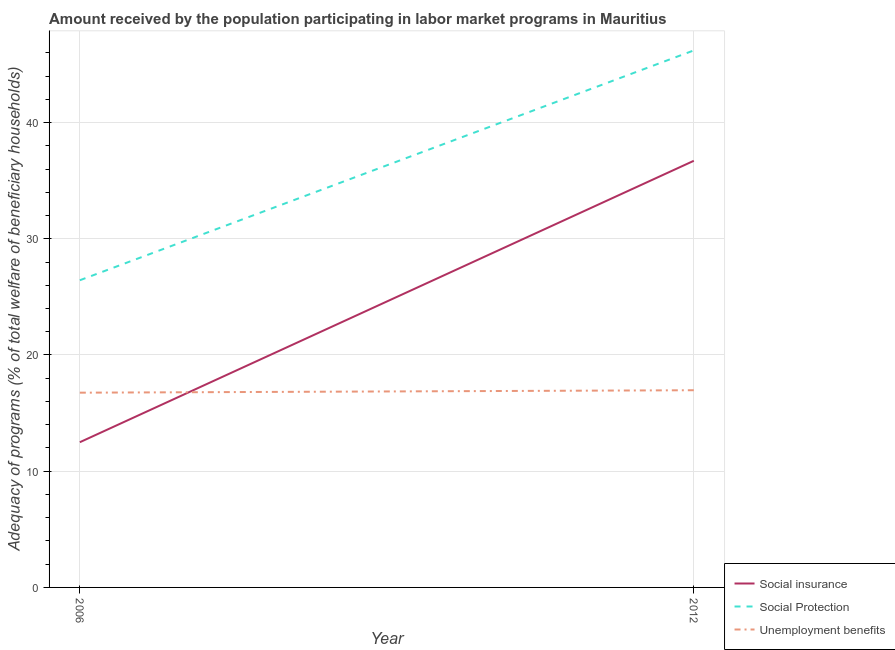How many different coloured lines are there?
Your response must be concise. 3. Is the number of lines equal to the number of legend labels?
Ensure brevity in your answer.  Yes. What is the amount received by the population participating in social protection programs in 2012?
Keep it short and to the point. 46.21. Across all years, what is the maximum amount received by the population participating in social insurance programs?
Your response must be concise. 36.71. Across all years, what is the minimum amount received by the population participating in social protection programs?
Ensure brevity in your answer.  26.43. What is the total amount received by the population participating in unemployment benefits programs in the graph?
Ensure brevity in your answer.  33.73. What is the difference between the amount received by the population participating in social insurance programs in 2006 and that in 2012?
Make the answer very short. -24.22. What is the difference between the amount received by the population participating in social protection programs in 2012 and the amount received by the population participating in social insurance programs in 2006?
Provide a succinct answer. 33.71. What is the average amount received by the population participating in unemployment benefits programs per year?
Your answer should be very brief. 16.86. In the year 2012, what is the difference between the amount received by the population participating in social insurance programs and amount received by the population participating in unemployment benefits programs?
Keep it short and to the point. 19.74. What is the ratio of the amount received by the population participating in social insurance programs in 2006 to that in 2012?
Give a very brief answer. 0.34. Is the amount received by the population participating in social protection programs in 2006 less than that in 2012?
Ensure brevity in your answer.  Yes. Is the amount received by the population participating in unemployment benefits programs strictly greater than the amount received by the population participating in social insurance programs over the years?
Make the answer very short. No. Is the amount received by the population participating in unemployment benefits programs strictly less than the amount received by the population participating in social insurance programs over the years?
Your response must be concise. No. How many years are there in the graph?
Provide a short and direct response. 2. What is the difference between two consecutive major ticks on the Y-axis?
Your answer should be very brief. 10. Where does the legend appear in the graph?
Make the answer very short. Bottom right. What is the title of the graph?
Ensure brevity in your answer.  Amount received by the population participating in labor market programs in Mauritius. Does "Negligence towards kids" appear as one of the legend labels in the graph?
Make the answer very short. No. What is the label or title of the Y-axis?
Provide a succinct answer. Adequacy of programs (% of total welfare of beneficiary households). What is the Adequacy of programs (% of total welfare of beneficiary households) in Social insurance in 2006?
Offer a very short reply. 12.49. What is the Adequacy of programs (% of total welfare of beneficiary households) of Social Protection in 2006?
Your response must be concise. 26.43. What is the Adequacy of programs (% of total welfare of beneficiary households) in Unemployment benefits in 2006?
Keep it short and to the point. 16.76. What is the Adequacy of programs (% of total welfare of beneficiary households) of Social insurance in 2012?
Offer a terse response. 36.71. What is the Adequacy of programs (% of total welfare of beneficiary households) of Social Protection in 2012?
Provide a short and direct response. 46.21. What is the Adequacy of programs (% of total welfare of beneficiary households) in Unemployment benefits in 2012?
Provide a short and direct response. 16.97. Across all years, what is the maximum Adequacy of programs (% of total welfare of beneficiary households) in Social insurance?
Offer a very short reply. 36.71. Across all years, what is the maximum Adequacy of programs (% of total welfare of beneficiary households) of Social Protection?
Offer a terse response. 46.21. Across all years, what is the maximum Adequacy of programs (% of total welfare of beneficiary households) in Unemployment benefits?
Your response must be concise. 16.97. Across all years, what is the minimum Adequacy of programs (% of total welfare of beneficiary households) of Social insurance?
Your answer should be compact. 12.49. Across all years, what is the minimum Adequacy of programs (% of total welfare of beneficiary households) of Social Protection?
Provide a succinct answer. 26.43. Across all years, what is the minimum Adequacy of programs (% of total welfare of beneficiary households) in Unemployment benefits?
Give a very brief answer. 16.76. What is the total Adequacy of programs (% of total welfare of beneficiary households) of Social insurance in the graph?
Give a very brief answer. 49.2. What is the total Adequacy of programs (% of total welfare of beneficiary households) of Social Protection in the graph?
Give a very brief answer. 72.64. What is the total Adequacy of programs (% of total welfare of beneficiary households) in Unemployment benefits in the graph?
Your answer should be compact. 33.73. What is the difference between the Adequacy of programs (% of total welfare of beneficiary households) of Social insurance in 2006 and that in 2012?
Ensure brevity in your answer.  -24.22. What is the difference between the Adequacy of programs (% of total welfare of beneficiary households) of Social Protection in 2006 and that in 2012?
Keep it short and to the point. -19.78. What is the difference between the Adequacy of programs (% of total welfare of beneficiary households) of Unemployment benefits in 2006 and that in 2012?
Give a very brief answer. -0.21. What is the difference between the Adequacy of programs (% of total welfare of beneficiary households) in Social insurance in 2006 and the Adequacy of programs (% of total welfare of beneficiary households) in Social Protection in 2012?
Provide a short and direct response. -33.71. What is the difference between the Adequacy of programs (% of total welfare of beneficiary households) in Social insurance in 2006 and the Adequacy of programs (% of total welfare of beneficiary households) in Unemployment benefits in 2012?
Make the answer very short. -4.47. What is the difference between the Adequacy of programs (% of total welfare of beneficiary households) of Social Protection in 2006 and the Adequacy of programs (% of total welfare of beneficiary households) of Unemployment benefits in 2012?
Your response must be concise. 9.46. What is the average Adequacy of programs (% of total welfare of beneficiary households) of Social insurance per year?
Ensure brevity in your answer.  24.6. What is the average Adequacy of programs (% of total welfare of beneficiary households) in Social Protection per year?
Offer a very short reply. 36.32. What is the average Adequacy of programs (% of total welfare of beneficiary households) in Unemployment benefits per year?
Your answer should be very brief. 16.86. In the year 2006, what is the difference between the Adequacy of programs (% of total welfare of beneficiary households) in Social insurance and Adequacy of programs (% of total welfare of beneficiary households) in Social Protection?
Provide a short and direct response. -13.94. In the year 2006, what is the difference between the Adequacy of programs (% of total welfare of beneficiary households) in Social insurance and Adequacy of programs (% of total welfare of beneficiary households) in Unemployment benefits?
Make the answer very short. -4.26. In the year 2006, what is the difference between the Adequacy of programs (% of total welfare of beneficiary households) in Social Protection and Adequacy of programs (% of total welfare of beneficiary households) in Unemployment benefits?
Give a very brief answer. 9.67. In the year 2012, what is the difference between the Adequacy of programs (% of total welfare of beneficiary households) in Social insurance and Adequacy of programs (% of total welfare of beneficiary households) in Social Protection?
Keep it short and to the point. -9.5. In the year 2012, what is the difference between the Adequacy of programs (% of total welfare of beneficiary households) of Social insurance and Adequacy of programs (% of total welfare of beneficiary households) of Unemployment benefits?
Your response must be concise. 19.74. In the year 2012, what is the difference between the Adequacy of programs (% of total welfare of beneficiary households) in Social Protection and Adequacy of programs (% of total welfare of beneficiary households) in Unemployment benefits?
Your response must be concise. 29.24. What is the ratio of the Adequacy of programs (% of total welfare of beneficiary households) of Social insurance in 2006 to that in 2012?
Give a very brief answer. 0.34. What is the ratio of the Adequacy of programs (% of total welfare of beneficiary households) of Social Protection in 2006 to that in 2012?
Your answer should be very brief. 0.57. What is the ratio of the Adequacy of programs (% of total welfare of beneficiary households) of Unemployment benefits in 2006 to that in 2012?
Ensure brevity in your answer.  0.99. What is the difference between the highest and the second highest Adequacy of programs (% of total welfare of beneficiary households) of Social insurance?
Offer a very short reply. 24.22. What is the difference between the highest and the second highest Adequacy of programs (% of total welfare of beneficiary households) of Social Protection?
Your answer should be very brief. 19.78. What is the difference between the highest and the second highest Adequacy of programs (% of total welfare of beneficiary households) in Unemployment benefits?
Make the answer very short. 0.21. What is the difference between the highest and the lowest Adequacy of programs (% of total welfare of beneficiary households) in Social insurance?
Give a very brief answer. 24.22. What is the difference between the highest and the lowest Adequacy of programs (% of total welfare of beneficiary households) in Social Protection?
Provide a short and direct response. 19.78. What is the difference between the highest and the lowest Adequacy of programs (% of total welfare of beneficiary households) of Unemployment benefits?
Your answer should be compact. 0.21. 